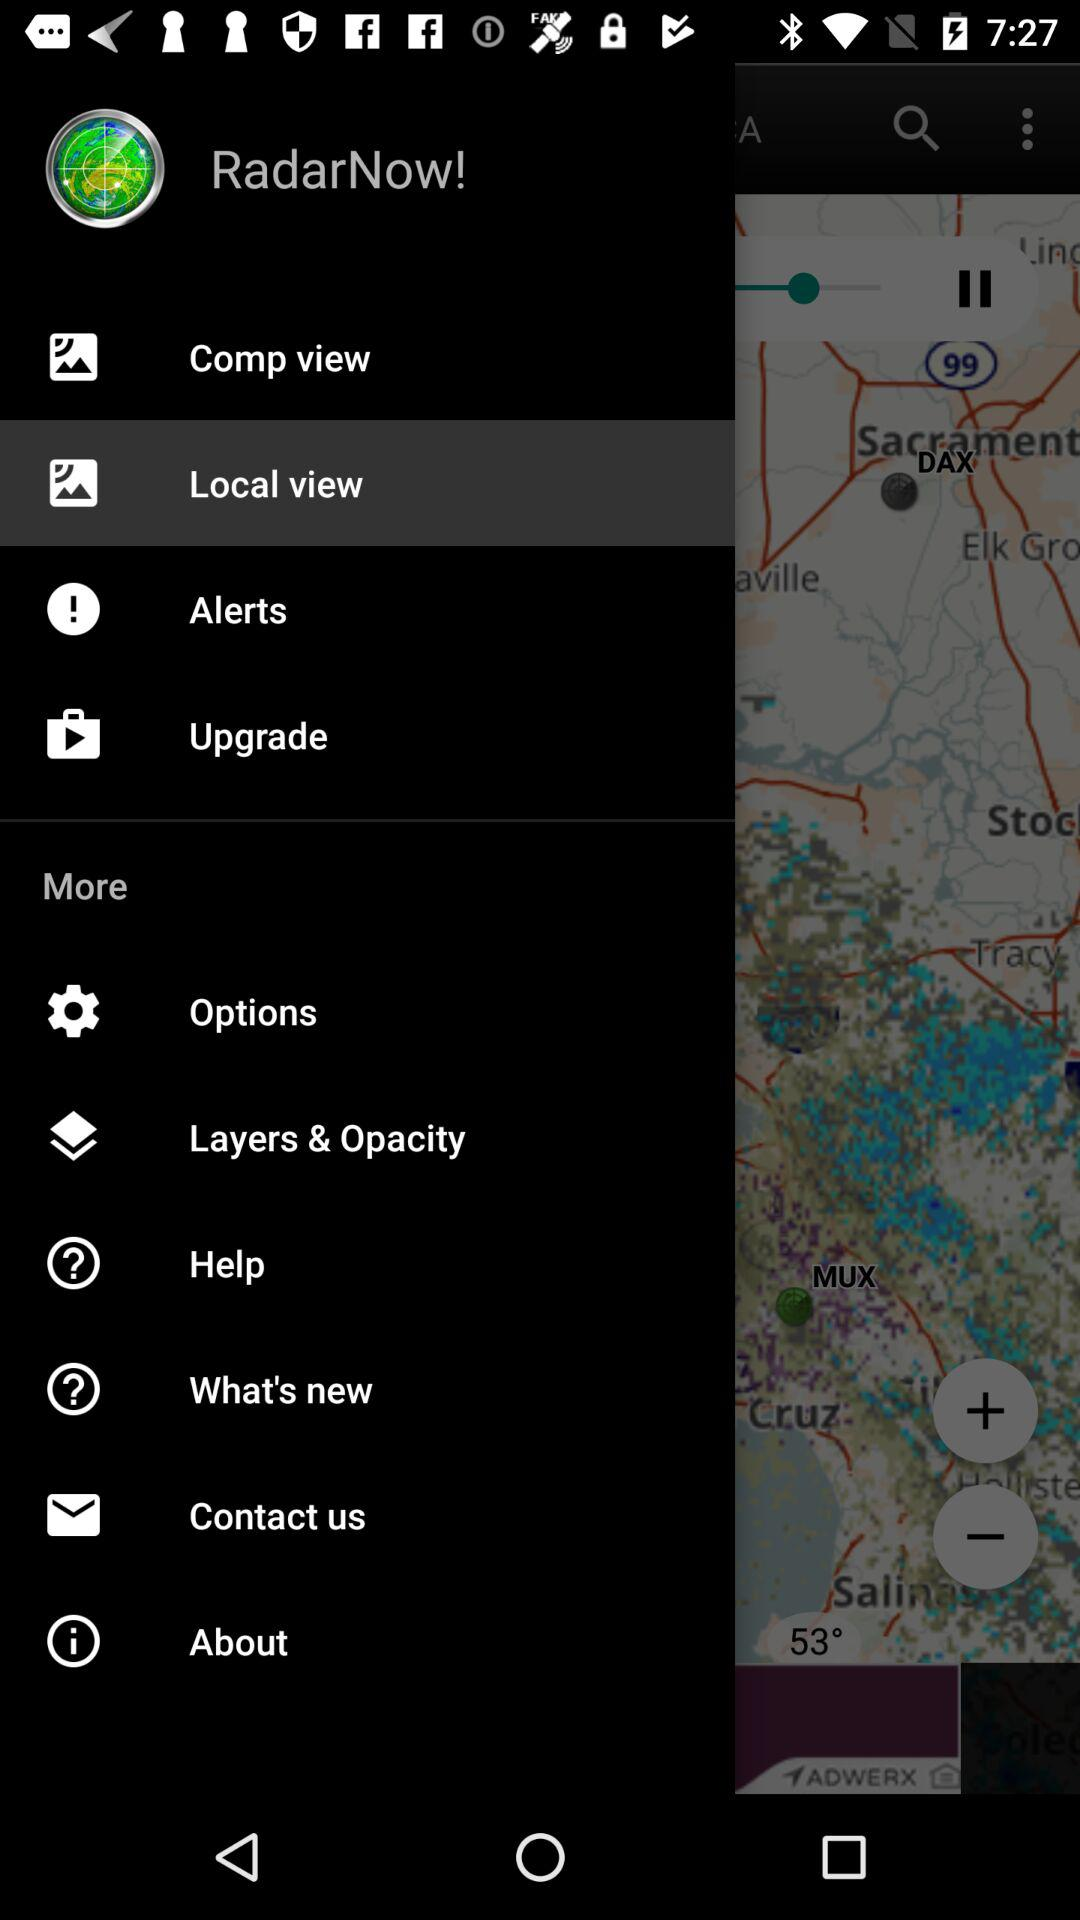What is the application name? The application name is "RadarNow!". 